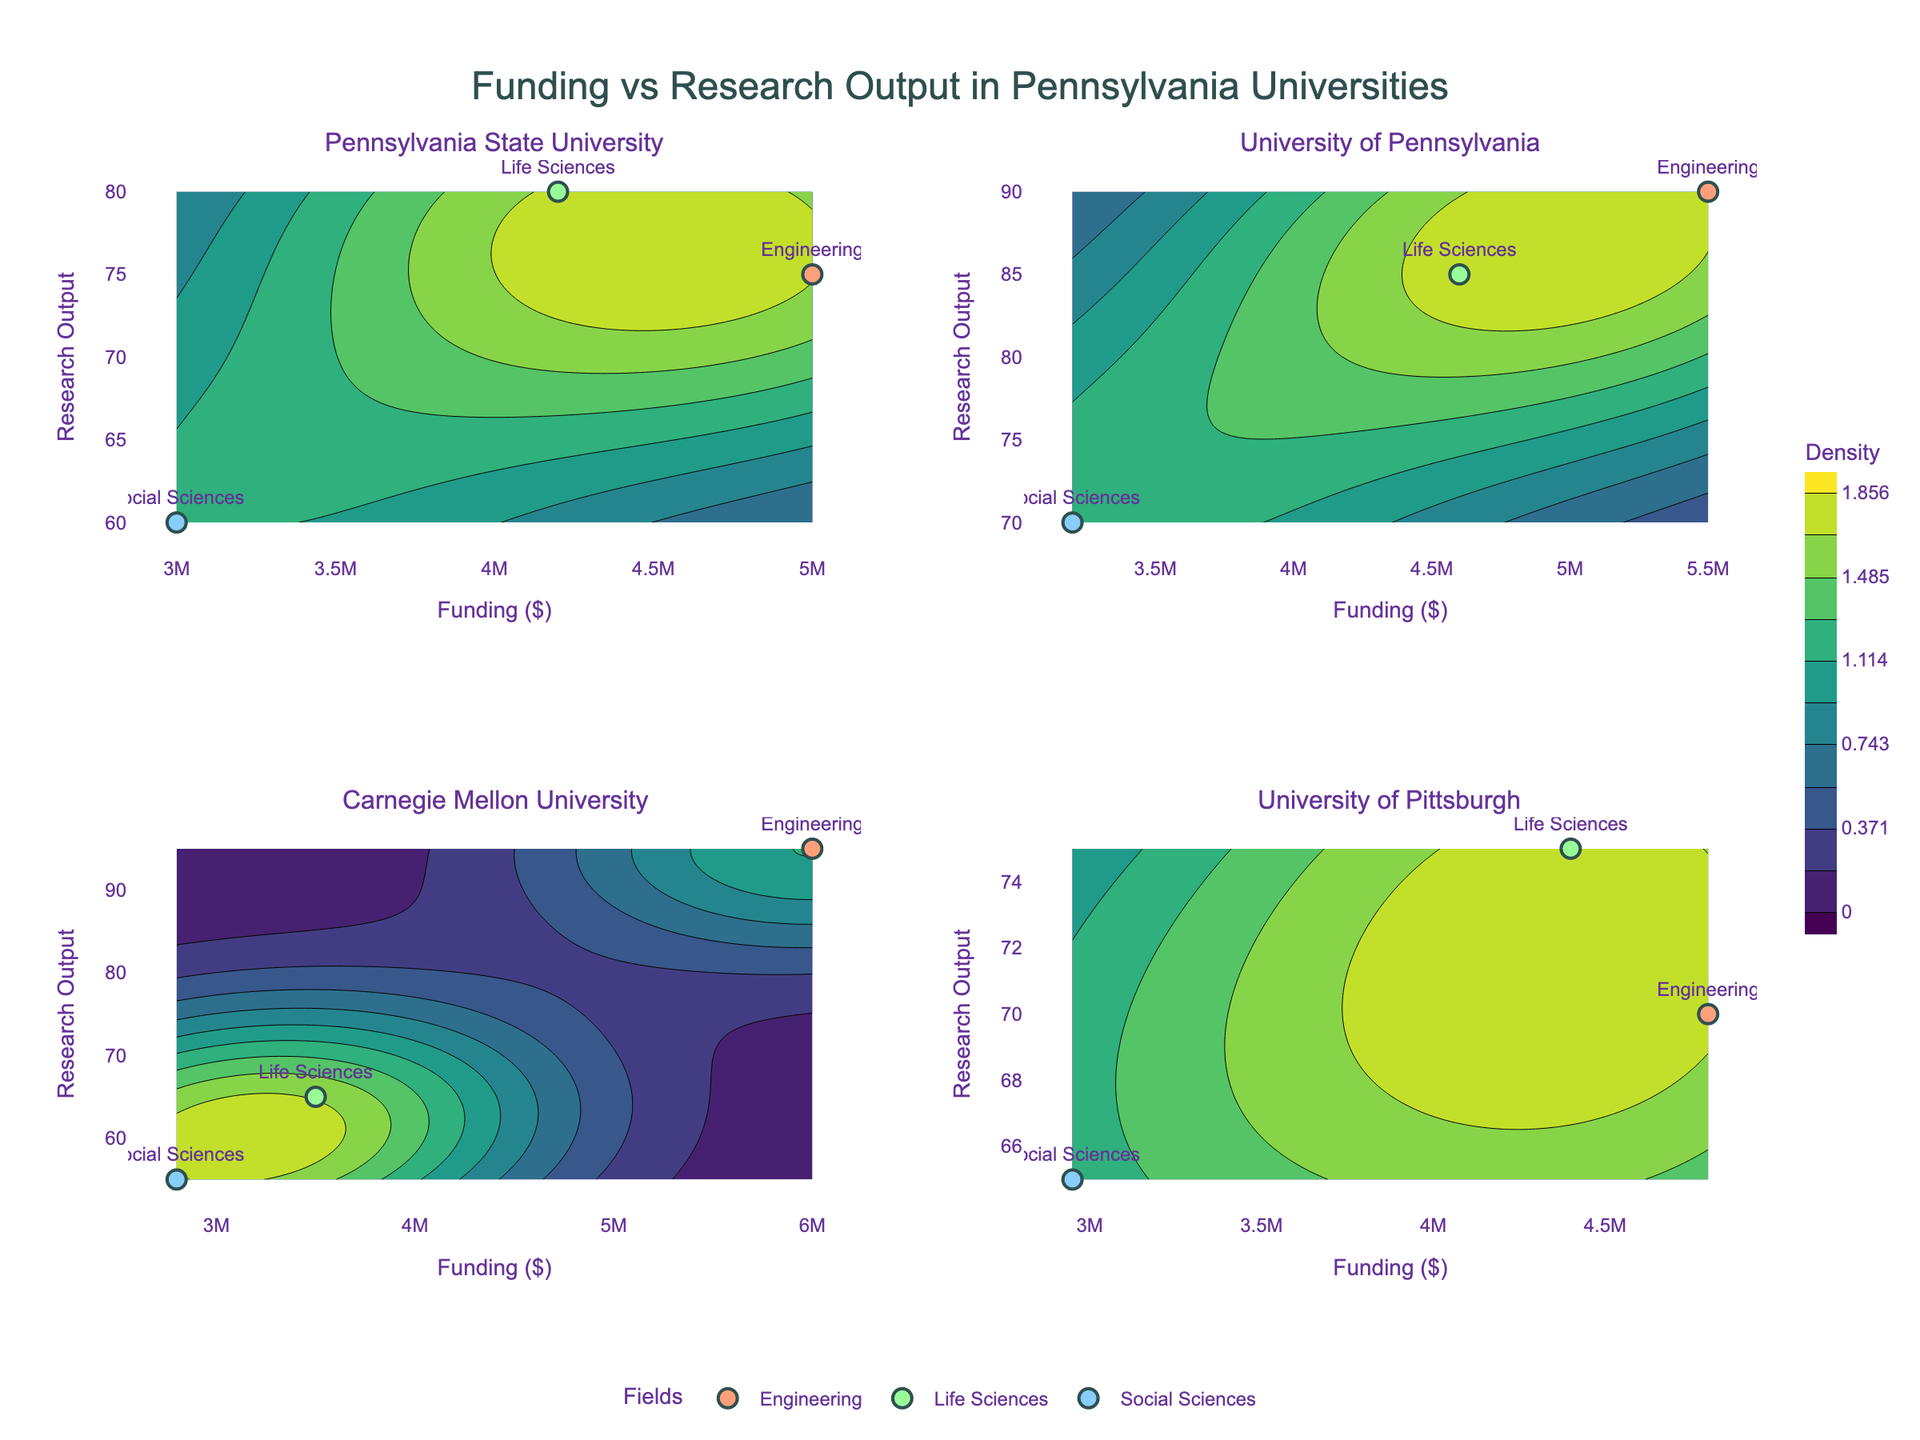Which university has the highest funding in the Engineering field? The subplot for each university shows data points for different fields. By checking the markers labeled 'Engineering,' Carnegie Mellon University has the highest funding in this field.
Answer: Carnegie Mellon University Which field at Pennsylvania State University has the lowest research output? Focus on the scatter points for Pennsylvania State University's subplot. The 'Social Sciences' field has the lowest research output.
Answer: Social Sciences Between University of Pennsylvania and University of Pittsburgh, which university has a higher maximum research output in Life Sciences? Compare the data points labeled 'Life Sciences' in the subplots for University of Pennsylvania and University of Pittsburgh. University of Pennsylvania has a higher research output in this field.
Answer: University of Pennsylvania What's the range of funding in Carnegie Mellon University's fields? Identify the minimum and maximum funding values in Carnegie Mellon University's subplot. The range spans from $2,800,000 to $6,000,000.
Answer: $2,800,000 to $6,000,000 Which university's fields show the highest density in the contour plot? Examine the contour plots and note the density levels. Carnegie Mellon University’s plot has the most concentrated regions with high density.
Answer: Carnegie Mellon University What is the average research output for Engineering fields across all universities? Calculate the average research output for the Engineering field by summing all outputs and dividing by the number of universities: (75 + 90 + 95 + 70) / 4 = 82.5.
Answer: 82.5 Is the funding for Social Sciences at Carnegie Mellon University higher or lower compared to other universities? Compare the Social Sciences funding in Carnegie Mellon University's subplot to those in other universities. Carnegie Mellon’s funding is lower.
Answer: Lower Which university has the most evenly distributed funding across different fields? Look at the scatter points within each subplot to assess the funding spread among fields. University of Pittsburgh shows a more balanced distribution.
Answer: University of Pittsburgh How does the research output for Social Sciences at University of Pennsylvania compare to University of Pittsburgh? Compare the scatter points labeled 'Social Sciences' in the subplots for these universities. University of Pennsylvania has higher research output.
Answer: University of Pennsylvania What is the primary color used for the field markers in the subplots? Observe the colors used for the markers in the subplots representing different fields. The primary colors are shades of orange, green, and blue.
Answer: Orange, green, and blue 